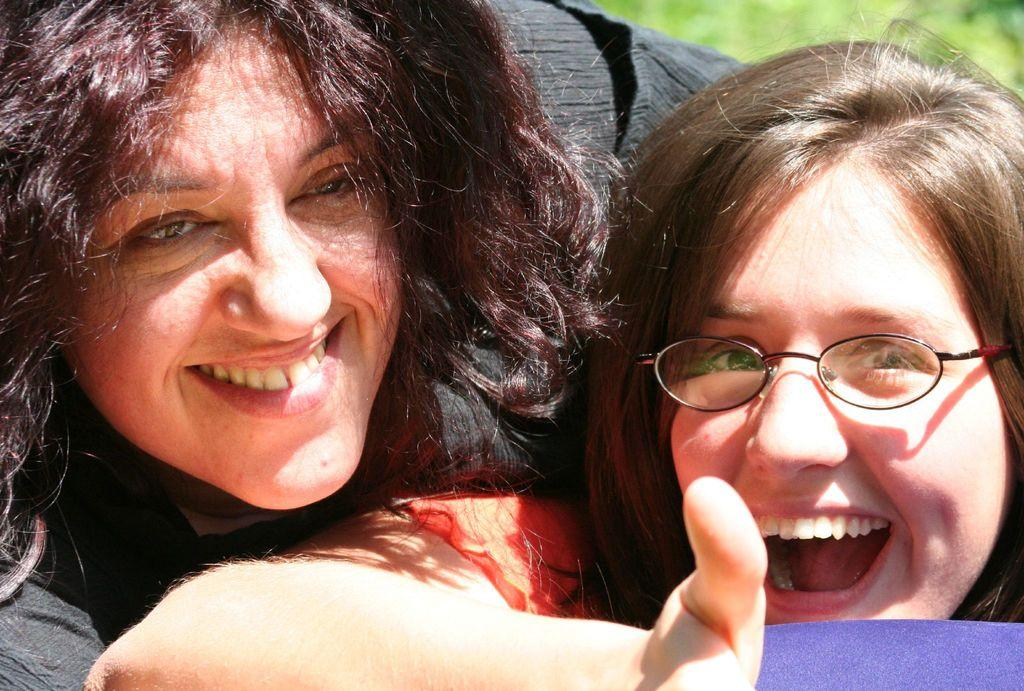How many people are in the image? There are two ladies in the image. What is the facial expression of the ladies in the image? Both ladies are smiling. What type of writing can be seen on the ladies' shirts in the image? There is no writing visible on the ladies' shirts in the image. Can you see any salt or wing-like objects in the image? There is no salt or wing-like objects present in the image. 